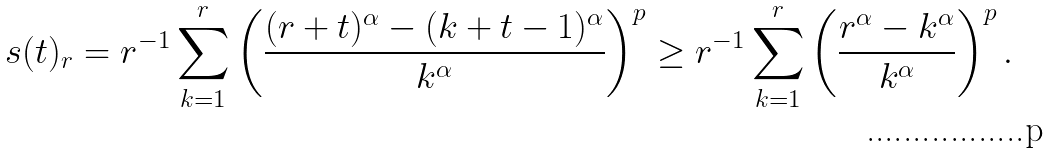<formula> <loc_0><loc_0><loc_500><loc_500>s ( t ) _ { r } = r ^ { - 1 } \sum ^ { r } _ { k = 1 } \left ( \frac { ( r + t ) ^ { \alpha } - ( k + t - 1 ) ^ { \alpha } } { k ^ { \alpha } } \right ) ^ { p } \geq r ^ { - 1 } \sum ^ { r } _ { k = 1 } \left ( \frac { r ^ { \alpha } - k ^ { \alpha } } { k ^ { \alpha } } \right ) ^ { p } .</formula> 